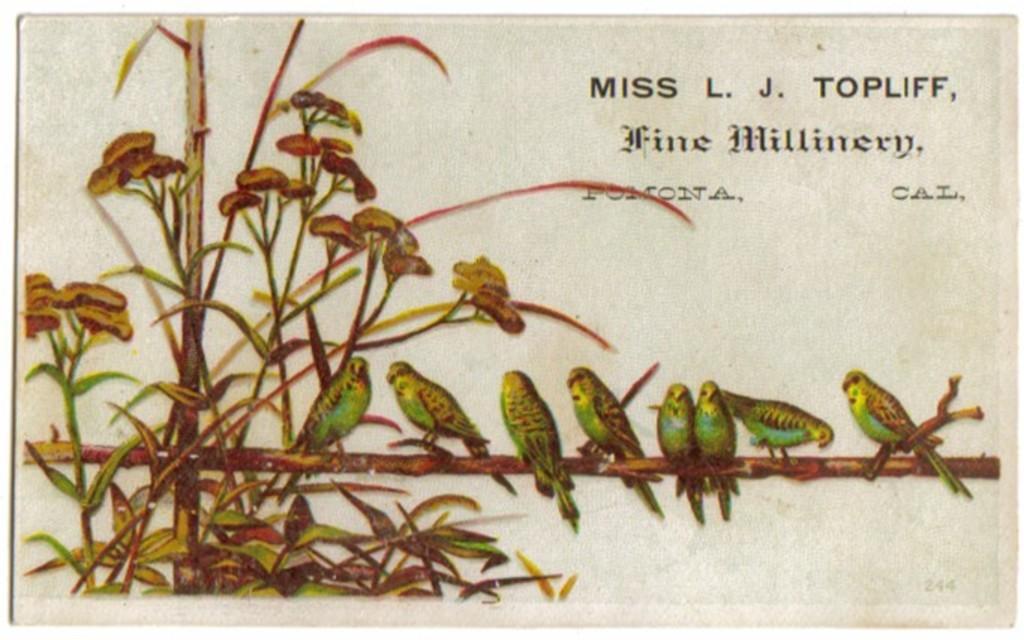Please provide a concise description of this image. In this image there is a painting. On a stick there are many birds standing. In the left there is a plant. On the top there are texts. 